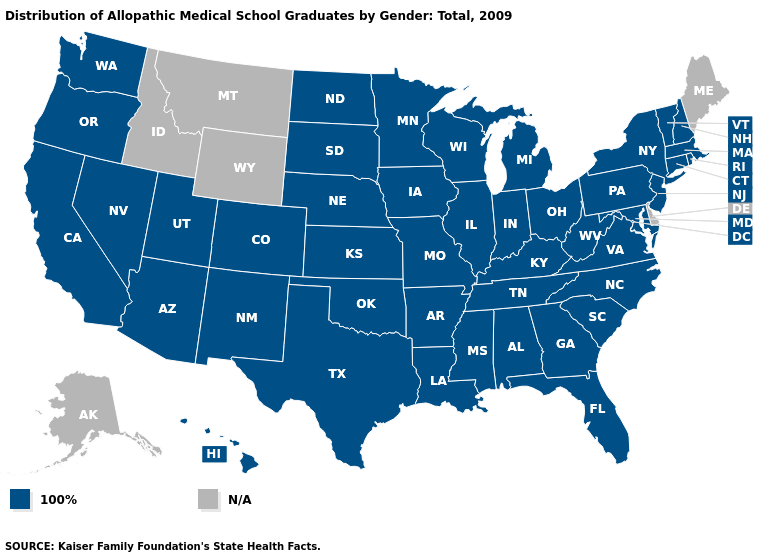Name the states that have a value in the range N/A?
Answer briefly. Alaska, Delaware, Idaho, Maine, Montana, Wyoming. What is the lowest value in the West?
Give a very brief answer. 100%. What is the value of Arizona?
Keep it brief. 100%. What is the value of Nevada?
Short answer required. 100%. What is the highest value in the USA?
Give a very brief answer. 100%. Name the states that have a value in the range 100%?
Write a very short answer. Alabama, Arizona, Arkansas, California, Colorado, Connecticut, Florida, Georgia, Hawaii, Illinois, Indiana, Iowa, Kansas, Kentucky, Louisiana, Maryland, Massachusetts, Michigan, Minnesota, Mississippi, Missouri, Nebraska, Nevada, New Hampshire, New Jersey, New Mexico, New York, North Carolina, North Dakota, Ohio, Oklahoma, Oregon, Pennsylvania, Rhode Island, South Carolina, South Dakota, Tennessee, Texas, Utah, Vermont, Virginia, Washington, West Virginia, Wisconsin. What is the value of Hawaii?
Concise answer only. 100%. Name the states that have a value in the range N/A?
Be succinct. Alaska, Delaware, Idaho, Maine, Montana, Wyoming. What is the highest value in the South ?
Concise answer only. 100%. What is the highest value in the MidWest ?
Answer briefly. 100%. Name the states that have a value in the range N/A?
Answer briefly. Alaska, Delaware, Idaho, Maine, Montana, Wyoming. What is the value of Maryland?
Be succinct. 100%. 